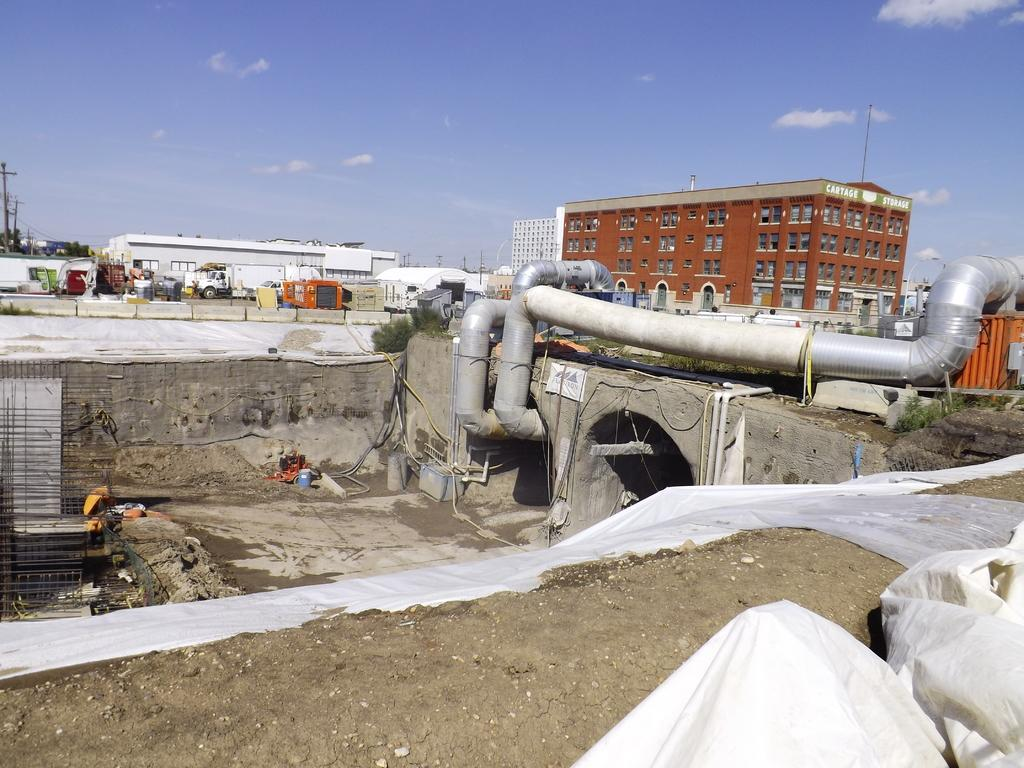What type of structures can be seen in the image? There are buildings in the image. What is the purpose of the fence in the image? The purpose of the fence in the image is not specified, but it could be for enclosing an area or providing a barrier. What type of transportation is visible in the image? There are vehicles in the image. What type of information is displayed in the image? Current polls are present in the image. What is the function of the pipe in the image? The function of the pipe in the image is not specified, but it could be for transporting water, gas, or other substances. What is visible at the top of the image? The sky is visible at the top of the image. Can you tell me how many muscles are visible in the image? There are no muscles visible in the image. Is there any quicksand present in the image? There is no quicksand present in the image. 